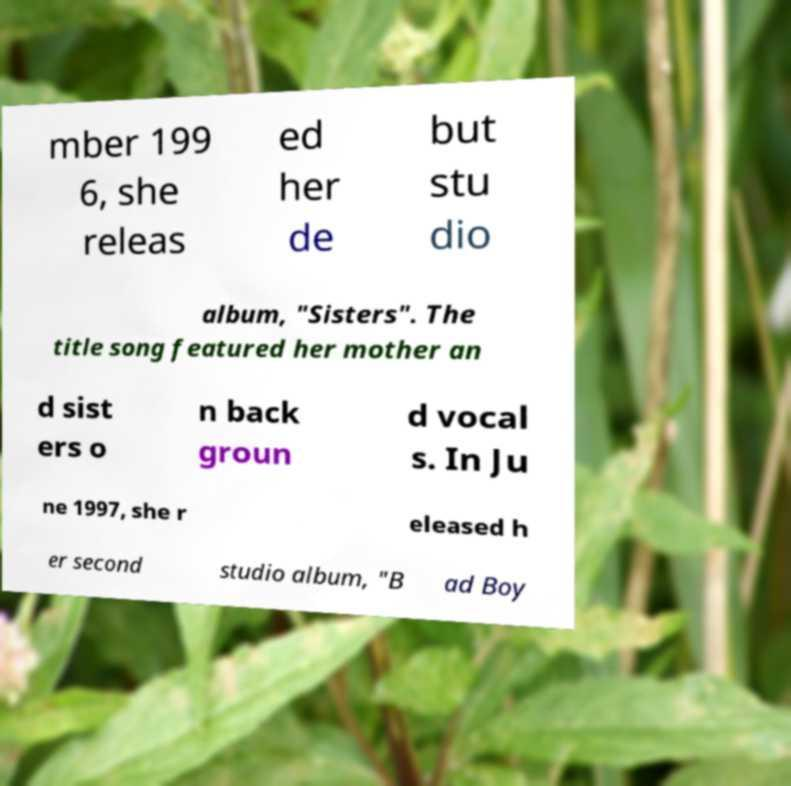Please identify and transcribe the text found in this image. mber 199 6, she releas ed her de but stu dio album, "Sisters". The title song featured her mother an d sist ers o n back groun d vocal s. In Ju ne 1997, she r eleased h er second studio album, "B ad Boy 